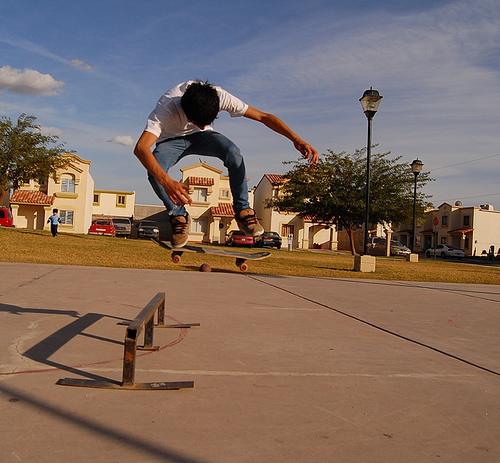What are they playing with?
Quick response, please. Skateboard. Is the boy wearing shorts?
Keep it brief. No. How many leaves are on the trees in the background?
Concise answer only. Lot. What is this boy jumping over?
Write a very short answer. Rail. What color is the boy's shirt?
Concise answer only. White. 